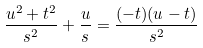<formula> <loc_0><loc_0><loc_500><loc_500>\frac { u ^ { 2 } + t ^ { 2 } } { s ^ { 2 } } + \frac { u } { s } = \frac { ( - t ) ( u - t ) } { s ^ { 2 } }</formula> 